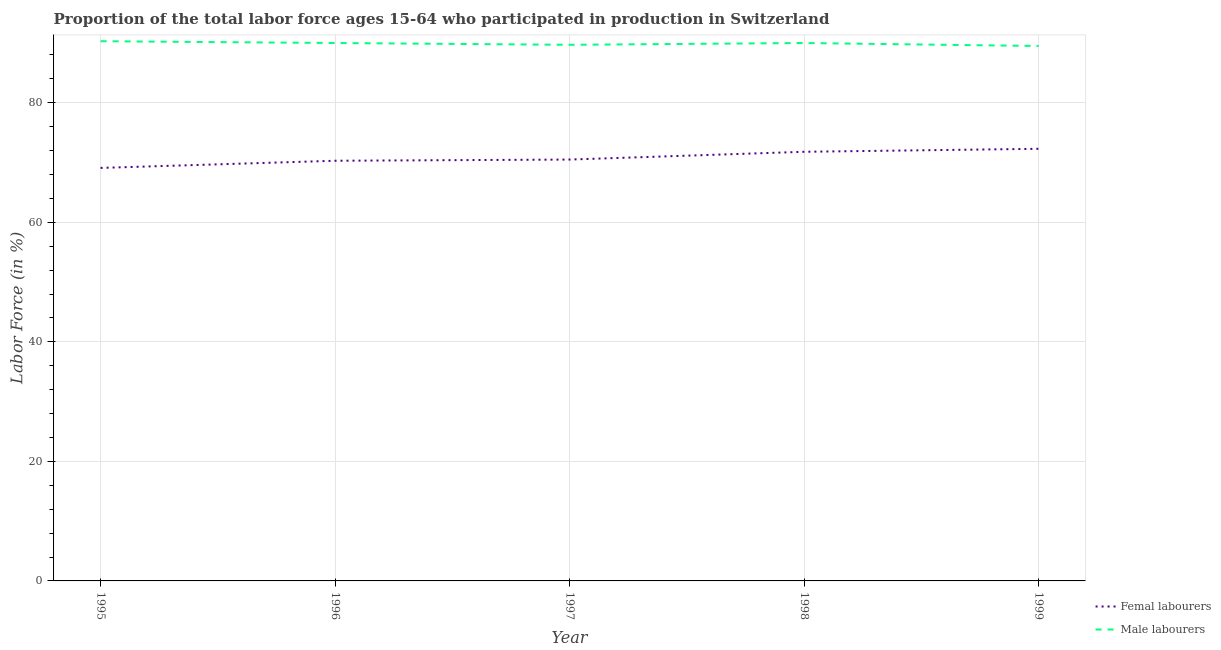Does the line corresponding to percentage of male labour force intersect with the line corresponding to percentage of female labor force?
Your answer should be very brief. No. What is the percentage of male labour force in 1995?
Your answer should be compact. 90.3. Across all years, what is the maximum percentage of male labour force?
Provide a succinct answer. 90.3. Across all years, what is the minimum percentage of female labor force?
Offer a terse response. 69.1. What is the total percentage of female labor force in the graph?
Ensure brevity in your answer.  354. What is the difference between the percentage of male labour force in 1995 and that in 1999?
Your response must be concise. 0.8. What is the average percentage of male labour force per year?
Your response must be concise. 89.9. In the year 1997, what is the difference between the percentage of male labour force and percentage of female labor force?
Your answer should be compact. 19.2. In how many years, is the percentage of male labour force greater than 24 %?
Offer a terse response. 5. What is the ratio of the percentage of male labour force in 1995 to that in 1999?
Provide a succinct answer. 1.01. Is the percentage of female labor force in 1995 less than that in 1996?
Offer a very short reply. Yes. Is the difference between the percentage of female labor force in 1995 and 1996 greater than the difference between the percentage of male labour force in 1995 and 1996?
Your answer should be compact. No. What is the difference between the highest and the second highest percentage of female labor force?
Give a very brief answer. 0.5. What is the difference between the highest and the lowest percentage of female labor force?
Your answer should be compact. 3.2. In how many years, is the percentage of male labour force greater than the average percentage of male labour force taken over all years?
Provide a short and direct response. 3. Is the sum of the percentage of female labor force in 1998 and 1999 greater than the maximum percentage of male labour force across all years?
Give a very brief answer. Yes. Is the percentage of female labor force strictly less than the percentage of male labour force over the years?
Your answer should be very brief. Yes. How many years are there in the graph?
Your answer should be compact. 5. Are the values on the major ticks of Y-axis written in scientific E-notation?
Provide a succinct answer. No. Does the graph contain any zero values?
Your response must be concise. No. What is the title of the graph?
Keep it short and to the point. Proportion of the total labor force ages 15-64 who participated in production in Switzerland. What is the label or title of the Y-axis?
Your response must be concise. Labor Force (in %). What is the Labor Force (in %) in Femal labourers in 1995?
Offer a terse response. 69.1. What is the Labor Force (in %) of Male labourers in 1995?
Your answer should be very brief. 90.3. What is the Labor Force (in %) of Femal labourers in 1996?
Offer a very short reply. 70.3. What is the Labor Force (in %) in Femal labourers in 1997?
Keep it short and to the point. 70.5. What is the Labor Force (in %) of Male labourers in 1997?
Your answer should be compact. 89.7. What is the Labor Force (in %) of Femal labourers in 1998?
Provide a short and direct response. 71.8. What is the Labor Force (in %) in Male labourers in 1998?
Your response must be concise. 90. What is the Labor Force (in %) in Femal labourers in 1999?
Provide a succinct answer. 72.3. What is the Labor Force (in %) in Male labourers in 1999?
Your answer should be very brief. 89.5. Across all years, what is the maximum Labor Force (in %) of Femal labourers?
Your answer should be very brief. 72.3. Across all years, what is the maximum Labor Force (in %) in Male labourers?
Offer a very short reply. 90.3. Across all years, what is the minimum Labor Force (in %) of Femal labourers?
Your answer should be compact. 69.1. Across all years, what is the minimum Labor Force (in %) of Male labourers?
Provide a succinct answer. 89.5. What is the total Labor Force (in %) of Femal labourers in the graph?
Offer a very short reply. 354. What is the total Labor Force (in %) in Male labourers in the graph?
Offer a terse response. 449.5. What is the difference between the Labor Force (in %) of Male labourers in 1995 and that in 1996?
Offer a very short reply. 0.3. What is the difference between the Labor Force (in %) of Femal labourers in 1995 and that in 1997?
Make the answer very short. -1.4. What is the difference between the Labor Force (in %) of Male labourers in 1995 and that in 1997?
Offer a terse response. 0.6. What is the difference between the Labor Force (in %) in Male labourers in 1995 and that in 1998?
Your answer should be compact. 0.3. What is the difference between the Labor Force (in %) of Femal labourers in 1995 and that in 1999?
Your answer should be compact. -3.2. What is the difference between the Labor Force (in %) in Male labourers in 1995 and that in 1999?
Provide a succinct answer. 0.8. What is the difference between the Labor Force (in %) of Femal labourers in 1996 and that in 1999?
Keep it short and to the point. -2. What is the difference between the Labor Force (in %) in Femal labourers in 1997 and that in 1998?
Offer a terse response. -1.3. What is the difference between the Labor Force (in %) in Male labourers in 1998 and that in 1999?
Your response must be concise. 0.5. What is the difference between the Labor Force (in %) of Femal labourers in 1995 and the Labor Force (in %) of Male labourers in 1996?
Ensure brevity in your answer.  -20.9. What is the difference between the Labor Force (in %) of Femal labourers in 1995 and the Labor Force (in %) of Male labourers in 1997?
Offer a terse response. -20.6. What is the difference between the Labor Force (in %) in Femal labourers in 1995 and the Labor Force (in %) in Male labourers in 1998?
Your answer should be very brief. -20.9. What is the difference between the Labor Force (in %) of Femal labourers in 1995 and the Labor Force (in %) of Male labourers in 1999?
Keep it short and to the point. -20.4. What is the difference between the Labor Force (in %) of Femal labourers in 1996 and the Labor Force (in %) of Male labourers in 1997?
Provide a succinct answer. -19.4. What is the difference between the Labor Force (in %) in Femal labourers in 1996 and the Labor Force (in %) in Male labourers in 1998?
Provide a short and direct response. -19.7. What is the difference between the Labor Force (in %) in Femal labourers in 1996 and the Labor Force (in %) in Male labourers in 1999?
Give a very brief answer. -19.2. What is the difference between the Labor Force (in %) of Femal labourers in 1997 and the Labor Force (in %) of Male labourers in 1998?
Provide a short and direct response. -19.5. What is the difference between the Labor Force (in %) in Femal labourers in 1997 and the Labor Force (in %) in Male labourers in 1999?
Offer a very short reply. -19. What is the difference between the Labor Force (in %) of Femal labourers in 1998 and the Labor Force (in %) of Male labourers in 1999?
Offer a terse response. -17.7. What is the average Labor Force (in %) of Femal labourers per year?
Provide a short and direct response. 70.8. What is the average Labor Force (in %) of Male labourers per year?
Offer a very short reply. 89.9. In the year 1995, what is the difference between the Labor Force (in %) in Femal labourers and Labor Force (in %) in Male labourers?
Offer a very short reply. -21.2. In the year 1996, what is the difference between the Labor Force (in %) in Femal labourers and Labor Force (in %) in Male labourers?
Provide a short and direct response. -19.7. In the year 1997, what is the difference between the Labor Force (in %) in Femal labourers and Labor Force (in %) in Male labourers?
Your answer should be compact. -19.2. In the year 1998, what is the difference between the Labor Force (in %) in Femal labourers and Labor Force (in %) in Male labourers?
Provide a short and direct response. -18.2. In the year 1999, what is the difference between the Labor Force (in %) in Femal labourers and Labor Force (in %) in Male labourers?
Offer a terse response. -17.2. What is the ratio of the Labor Force (in %) of Femal labourers in 1995 to that in 1996?
Give a very brief answer. 0.98. What is the ratio of the Labor Force (in %) of Femal labourers in 1995 to that in 1997?
Provide a succinct answer. 0.98. What is the ratio of the Labor Force (in %) in Femal labourers in 1995 to that in 1998?
Provide a short and direct response. 0.96. What is the ratio of the Labor Force (in %) of Male labourers in 1995 to that in 1998?
Make the answer very short. 1. What is the ratio of the Labor Force (in %) in Femal labourers in 1995 to that in 1999?
Offer a very short reply. 0.96. What is the ratio of the Labor Force (in %) in Male labourers in 1995 to that in 1999?
Offer a very short reply. 1.01. What is the ratio of the Labor Force (in %) of Femal labourers in 1996 to that in 1998?
Make the answer very short. 0.98. What is the ratio of the Labor Force (in %) of Femal labourers in 1996 to that in 1999?
Your response must be concise. 0.97. What is the ratio of the Labor Force (in %) of Male labourers in 1996 to that in 1999?
Offer a very short reply. 1.01. What is the ratio of the Labor Force (in %) in Femal labourers in 1997 to that in 1998?
Your answer should be compact. 0.98. What is the ratio of the Labor Force (in %) of Femal labourers in 1997 to that in 1999?
Keep it short and to the point. 0.98. What is the ratio of the Labor Force (in %) in Male labourers in 1997 to that in 1999?
Give a very brief answer. 1. What is the ratio of the Labor Force (in %) of Male labourers in 1998 to that in 1999?
Your response must be concise. 1.01. What is the difference between the highest and the second highest Labor Force (in %) of Male labourers?
Your response must be concise. 0.3. What is the difference between the highest and the lowest Labor Force (in %) of Male labourers?
Offer a very short reply. 0.8. 